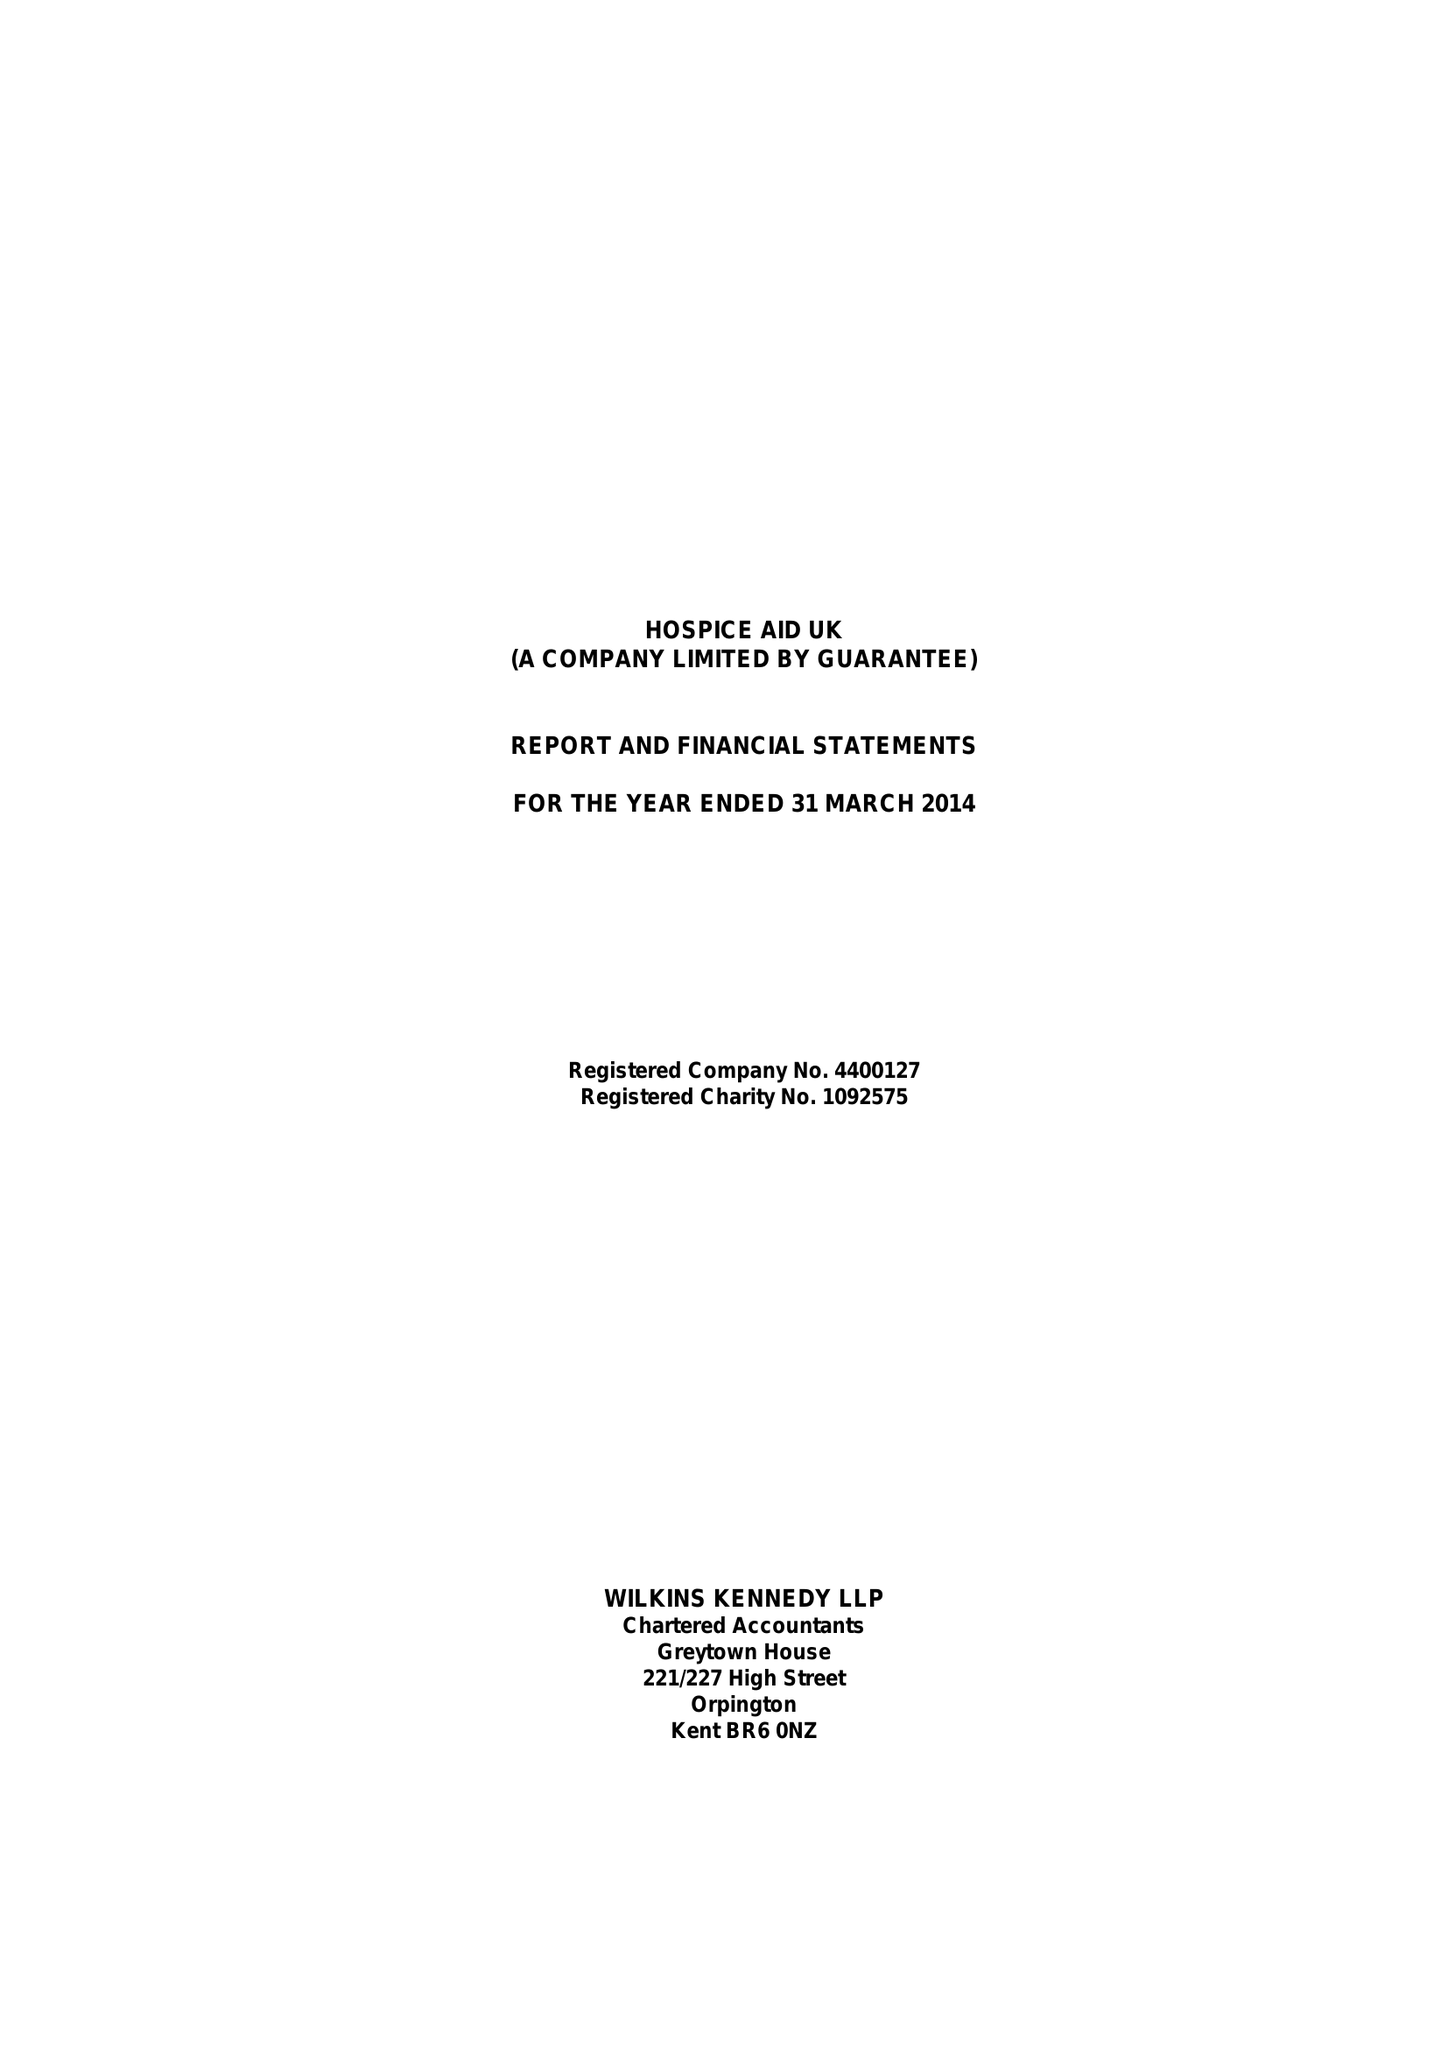What is the value for the address__post_town?
Answer the question using a single word or phrase. CRAWLEY 